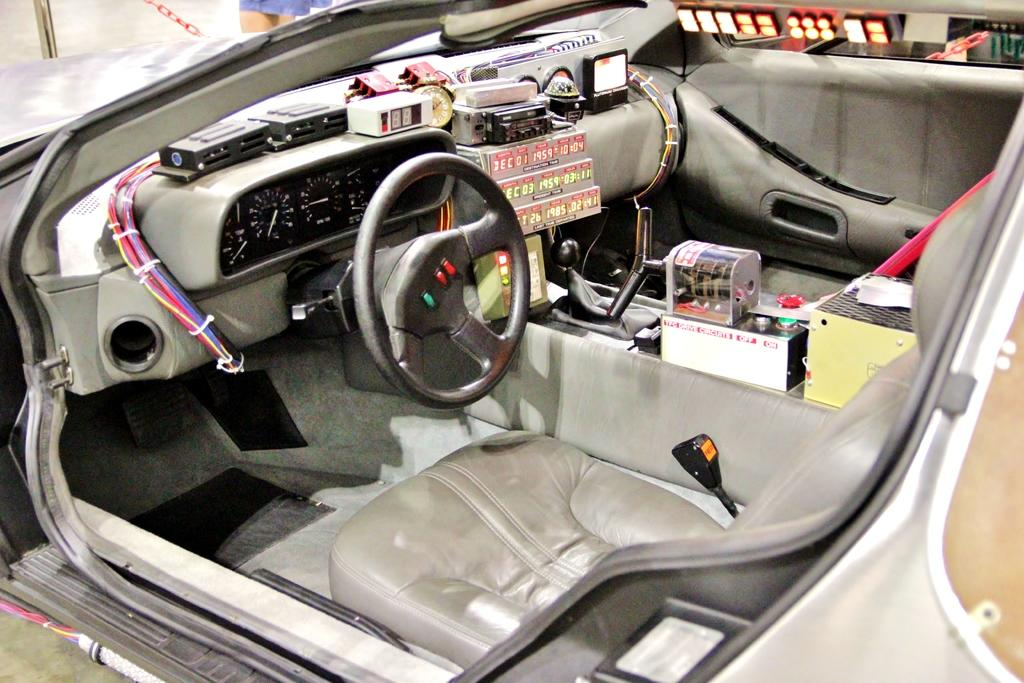What is the main subject of the image? The main subject of the image is a car. What features does the car have? The car has seats, a steering wheel, wires, boxes, a clock, and a floor. Can you describe the interior of the car? The interior of the car includes seats, a steering wheel, wires, boxes, and a clock. What type of soda is being served in the car? There is no soda present in the image; the image only shows a car with various interior features. How much is the payment for the car in the image? There is no indication of payment or cost in the image; it only shows the interior of the car. 